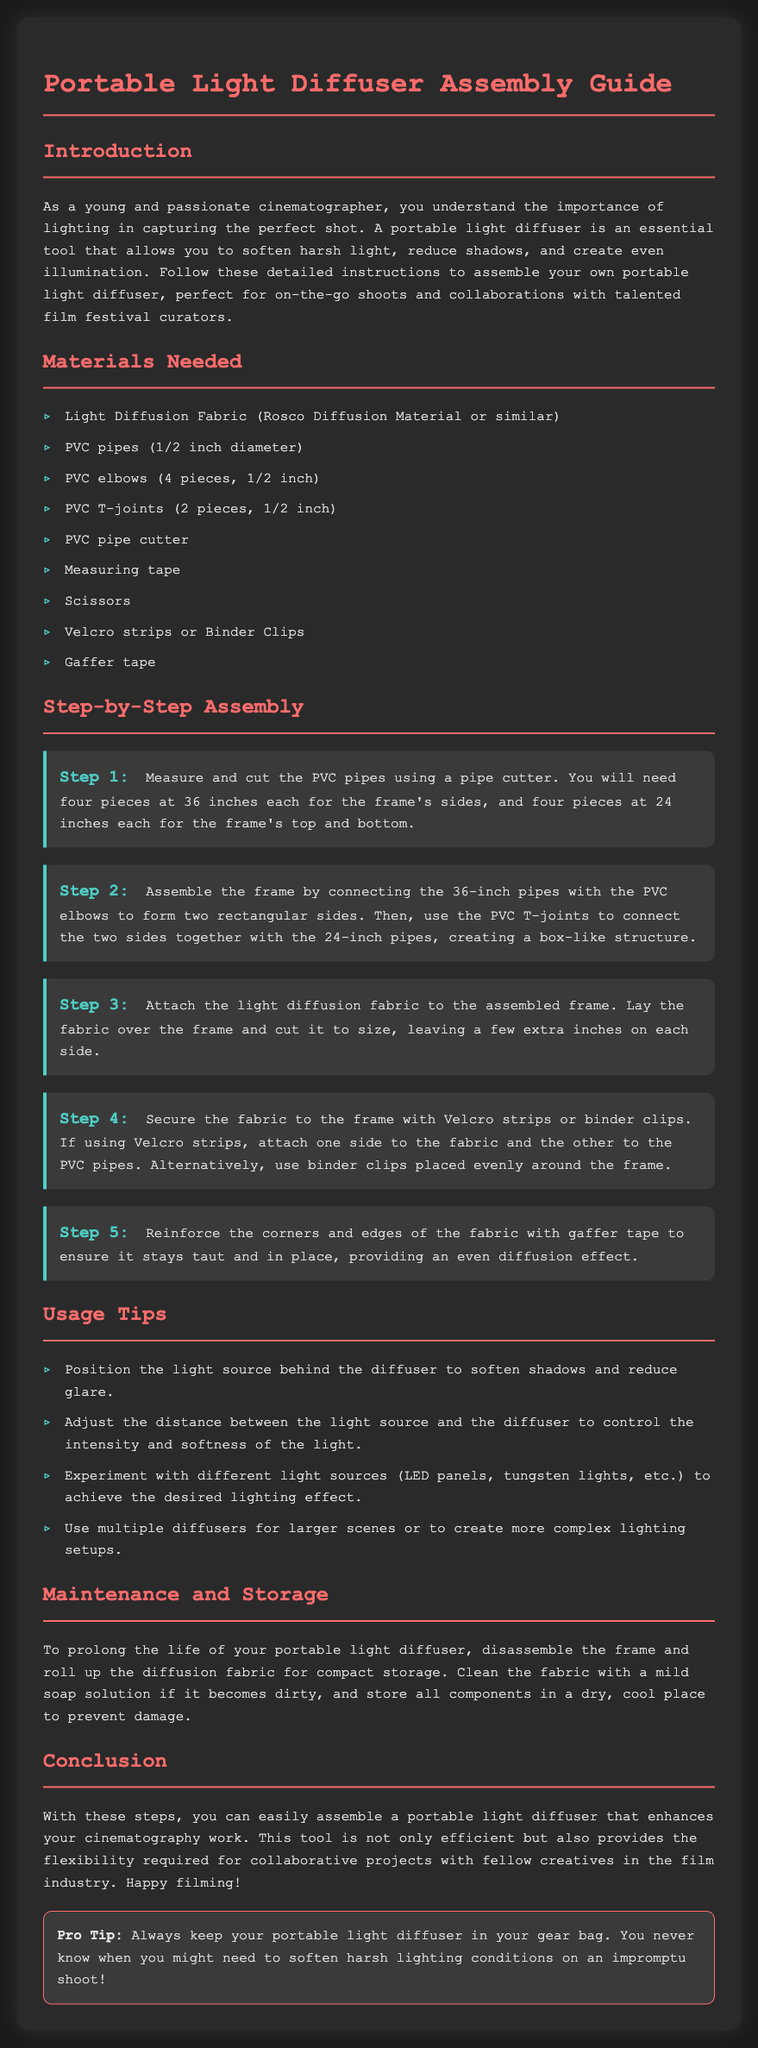what materials are needed for assembly? The materials are listed in the "Materials Needed" section, including light diffusion fabric, PVC pipes, PVC elbows, and other items.
Answer: Light Diffusion Fabric, PVC pipes, PVC elbows, PVC T-joints, PVC pipe cutter, measuring tape, scissors, Velcro strips, gaffer tape how many PVC elbows are required? The document specifies that you need four pieces of PVC elbows for assembly.
Answer: 4 pieces what is the length of the PVC pipes needed for the sides? The document indicates that the PVC pipes for the sides should be cut to 36 inches each.
Answer: 36 inches which step involves attaching the diffusion fabric? Step 3 mentions the process of attaching the light diffusion fabric to the assembled frame.
Answer: Step 3 what should be used to secure the fabric to the frame? The document states you can use Velcro strips or binder clips to secure the fabric.
Answer: Velcro strips or binder clips how many light sources are suggested to experiment with? The "Usage Tips" section suggests experimenting with different light sources, referring to multiple sources including LED panels and tungsten lights.
Answer: Multiple light sources what is a pro tip mentioned in the document? The pro tip suggests keeping the portable light diffuser in your gear bag for unexpected shoots.
Answer: Keep your portable light diffuser in your gear bag how should the fabric be cleaned if dirty? The document mentions using a mild soap solution to clean the fabric if it becomes dirty.
Answer: Mild soap solution 